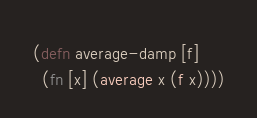Convert code to text. <code><loc_0><loc_0><loc_500><loc_500><_Clojure_>(defn average-damp [f]  
  (fn [x] (average x (f x))))
</code> 